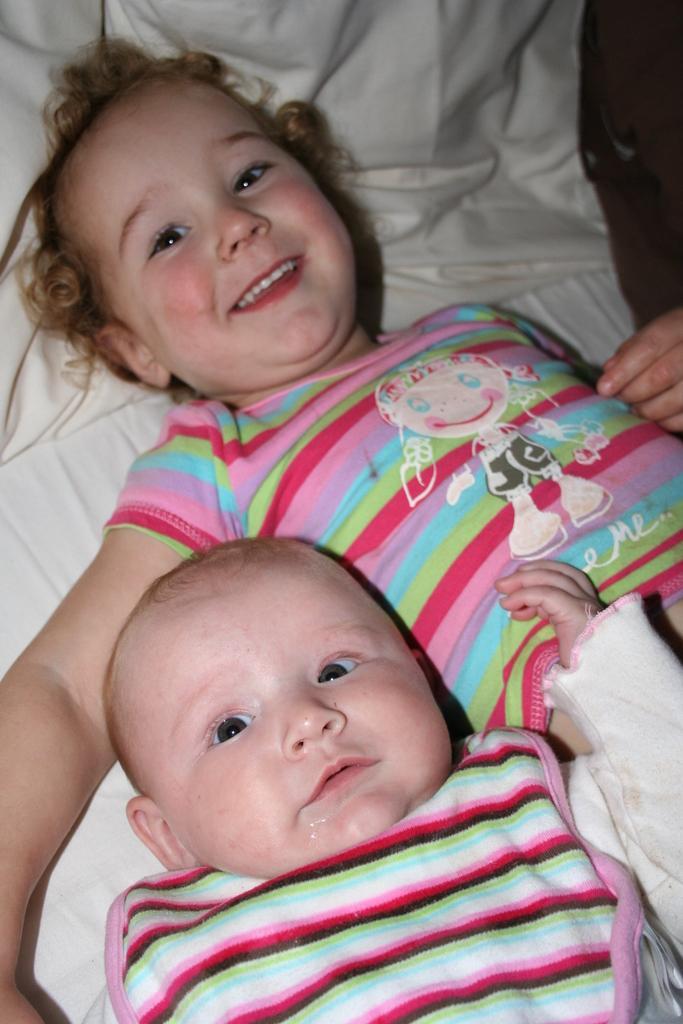How would you summarize this image in a sentence or two? In this picture I can see a kid and a baby laying on the bed. 